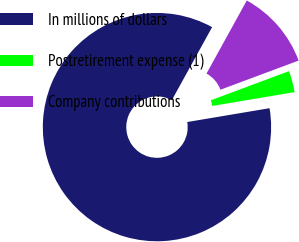<chart> <loc_0><loc_0><loc_500><loc_500><pie_chart><fcel>In millions of dollars<fcel>Postretirement expense (1)<fcel>Company contributions<nl><fcel>85.67%<fcel>3.03%<fcel>11.3%<nl></chart> 